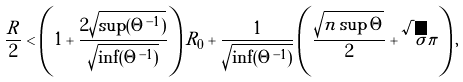<formula> <loc_0><loc_0><loc_500><loc_500>\frac { R } { 2 } < \left ( 1 + \frac { 2 \sqrt { \sup ( \Theta ^ { - 1 } ) } } { \sqrt { \inf ( \Theta ^ { - 1 } ) } } \right ) R _ { 0 } + \frac { 1 } { \sqrt { \inf ( \Theta ^ { - 1 } ) } } \left ( \frac { \sqrt { n \sup \Theta } } { 2 } + \sqrt { \sigma } \pi \right ) ,</formula> 